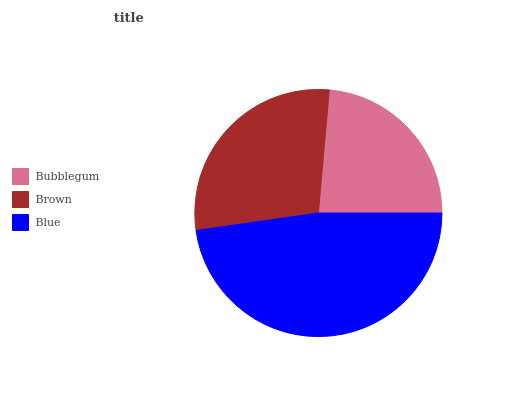Is Bubblegum the minimum?
Answer yes or no. Yes. Is Blue the maximum?
Answer yes or no. Yes. Is Brown the minimum?
Answer yes or no. No. Is Brown the maximum?
Answer yes or no. No. Is Brown greater than Bubblegum?
Answer yes or no. Yes. Is Bubblegum less than Brown?
Answer yes or no. Yes. Is Bubblegum greater than Brown?
Answer yes or no. No. Is Brown less than Bubblegum?
Answer yes or no. No. Is Brown the high median?
Answer yes or no. Yes. Is Brown the low median?
Answer yes or no. Yes. Is Bubblegum the high median?
Answer yes or no. No. Is Bubblegum the low median?
Answer yes or no. No. 